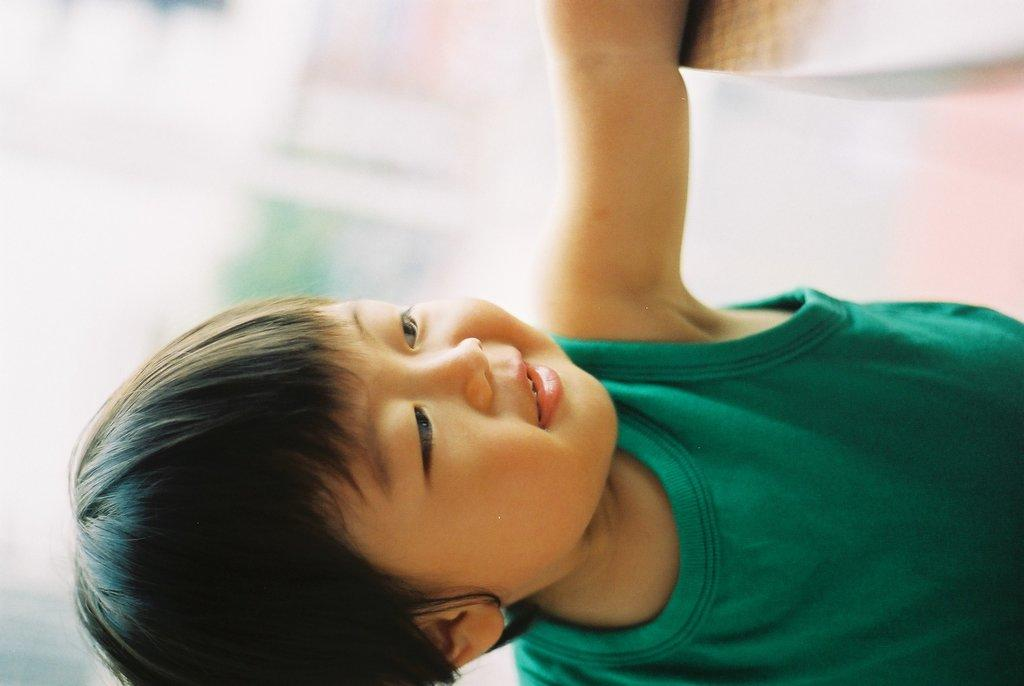What is the main subject of the image? The main subject of the image is a kid. What is the kid wearing in the image? The kid is wearing a green dress in the image. Reasoning: Let' Let's think step by step in order to produce the conversation. We start by identifying the main subject of the image, which is the kid. Then, we describe the clothing the kid is wearing, which is a green dress. We avoid asking questions that cannot be answered definitively with the information given and ensure that the language is simple and clear. Absurd Question/Answer: What month is it in the image? There is no information about the month in the image. What songs is the kid singing in the image? There is no information about the kid singing any songs in the image. 